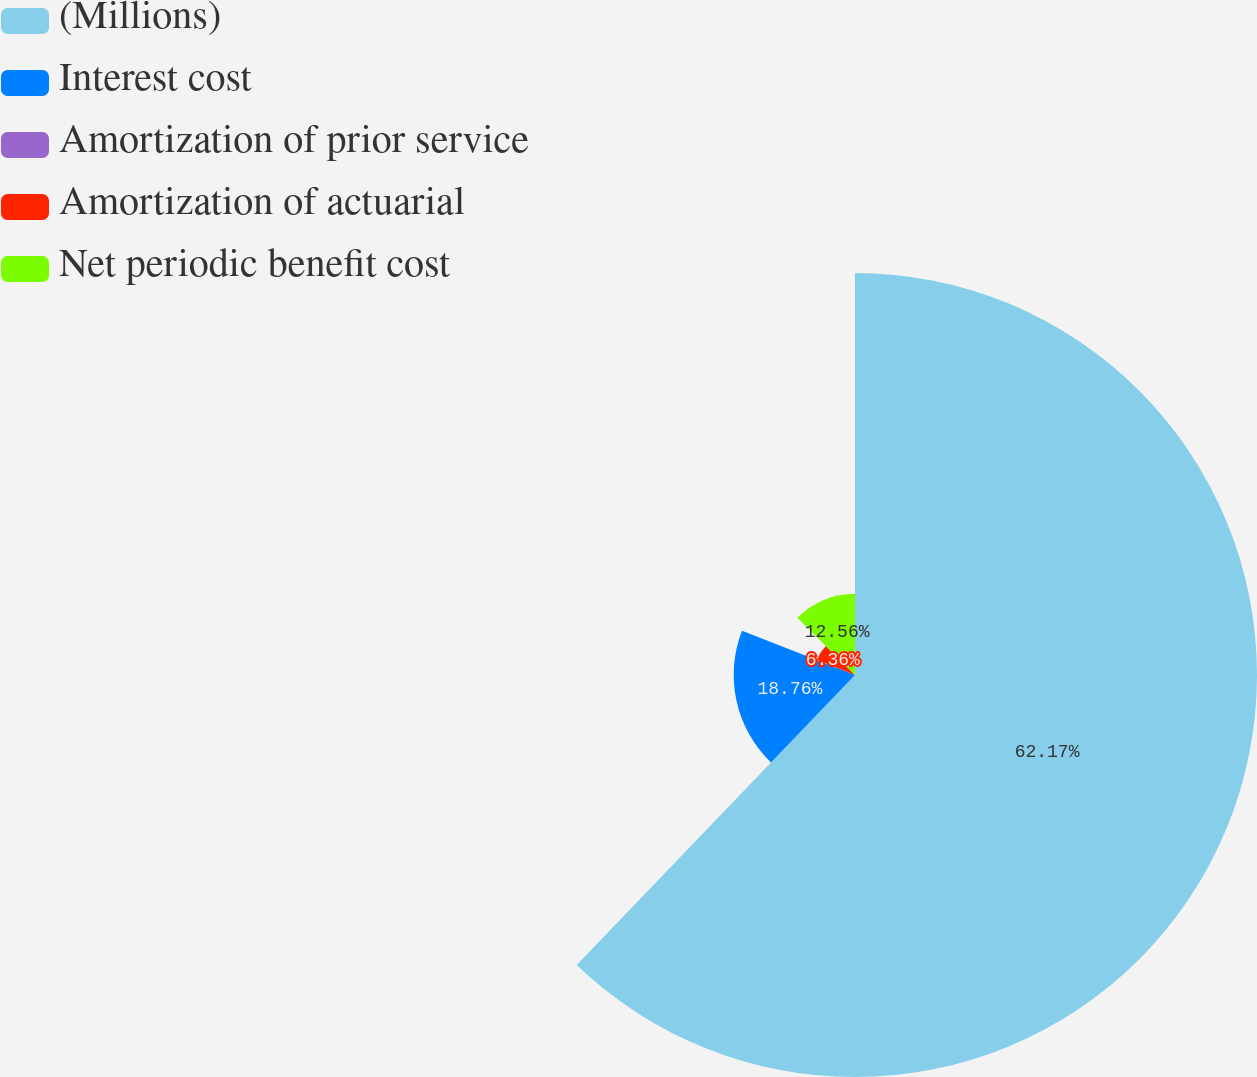<chart> <loc_0><loc_0><loc_500><loc_500><pie_chart><fcel>(Millions)<fcel>Interest cost<fcel>Amortization of prior service<fcel>Amortization of actuarial<fcel>Net periodic benefit cost<nl><fcel>62.17%<fcel>18.76%<fcel>0.15%<fcel>6.36%<fcel>12.56%<nl></chart> 